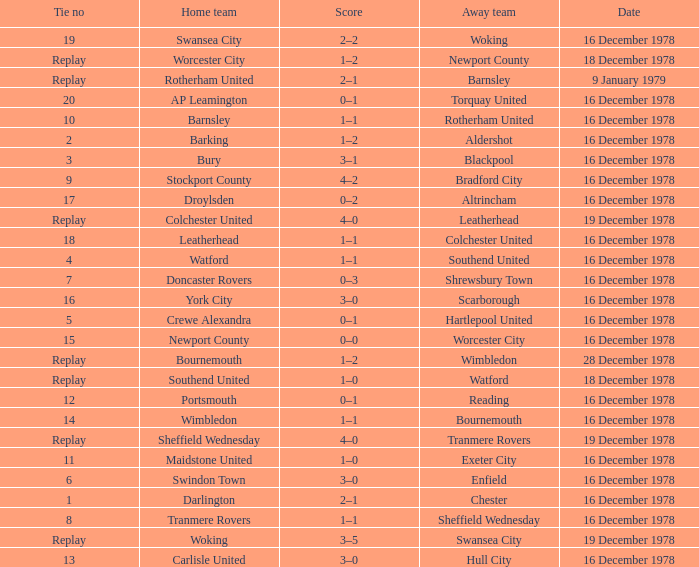What is the tie no for the home team swansea city? 19.0. 